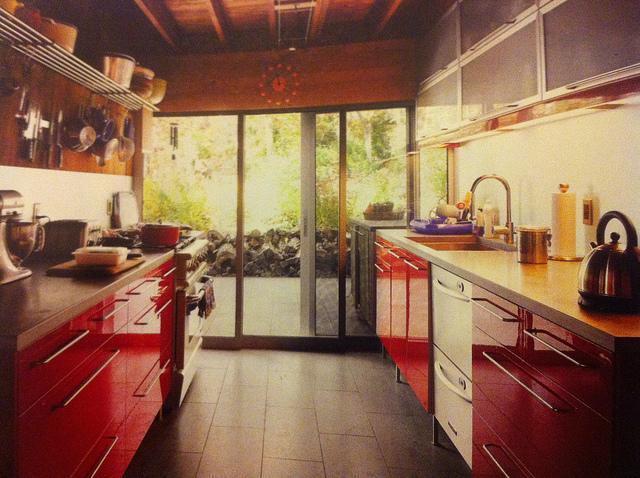How many zebras do you see?
Give a very brief answer. 0. 